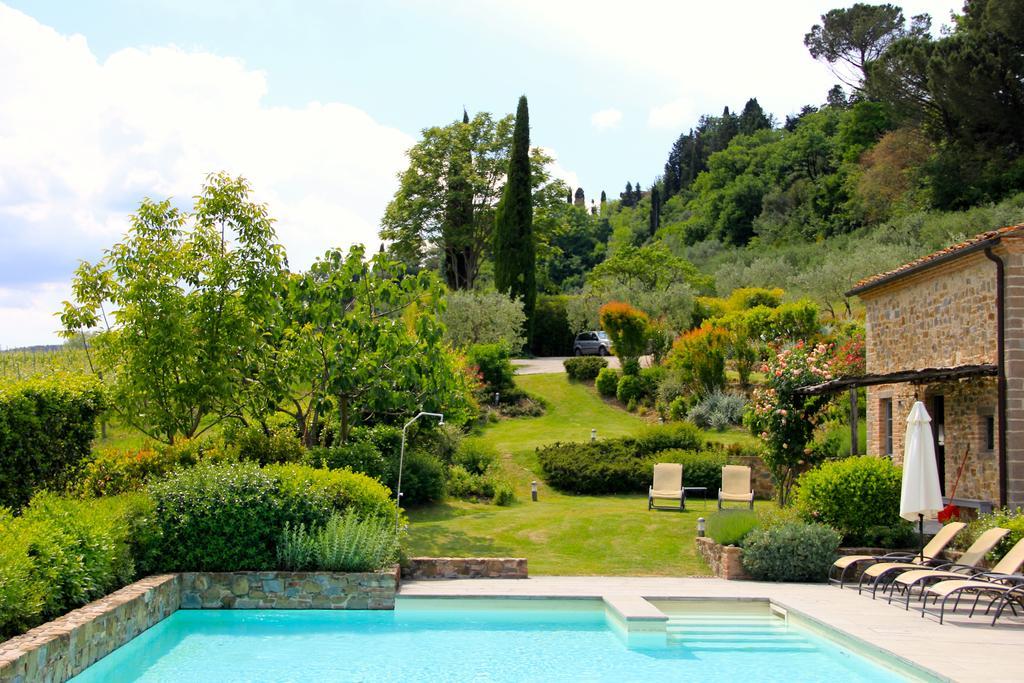In one or two sentences, can you explain what this image depicts? In the image we can see there is a swimming pool and there are plants and trees. There are chairs kept on the ground and behind there is a building. The ground is covered with grass and there is a clear sky. 